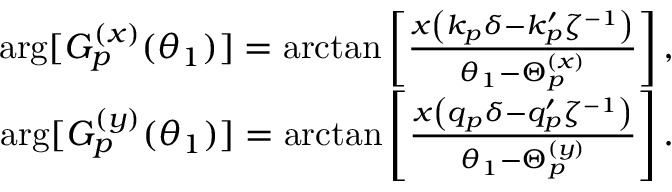Convert formula to latex. <formula><loc_0><loc_0><loc_500><loc_500>\begin{array} { r } { \arg [ G _ { p } ^ { ( x ) } ( \theta _ { 1 } ) ] = \arctan \left [ \frac { x \left ( k _ { p } \delta - k _ { p } ^ { \prime } \zeta ^ { - 1 } \right ) } { \theta _ { 1 } - \Theta _ { p } ^ { ( x ) } } \right ] , } \\ { \arg [ G _ { p } ^ { ( y ) } ( \theta _ { 1 } ) ] = \arctan \left [ \frac { x \left ( q _ { p } \delta - q _ { p } ^ { \prime } \zeta ^ { - 1 } \right ) } { \theta _ { 1 } - \Theta _ { p } ^ { ( y ) } } \right ] . } \end{array}</formula> 